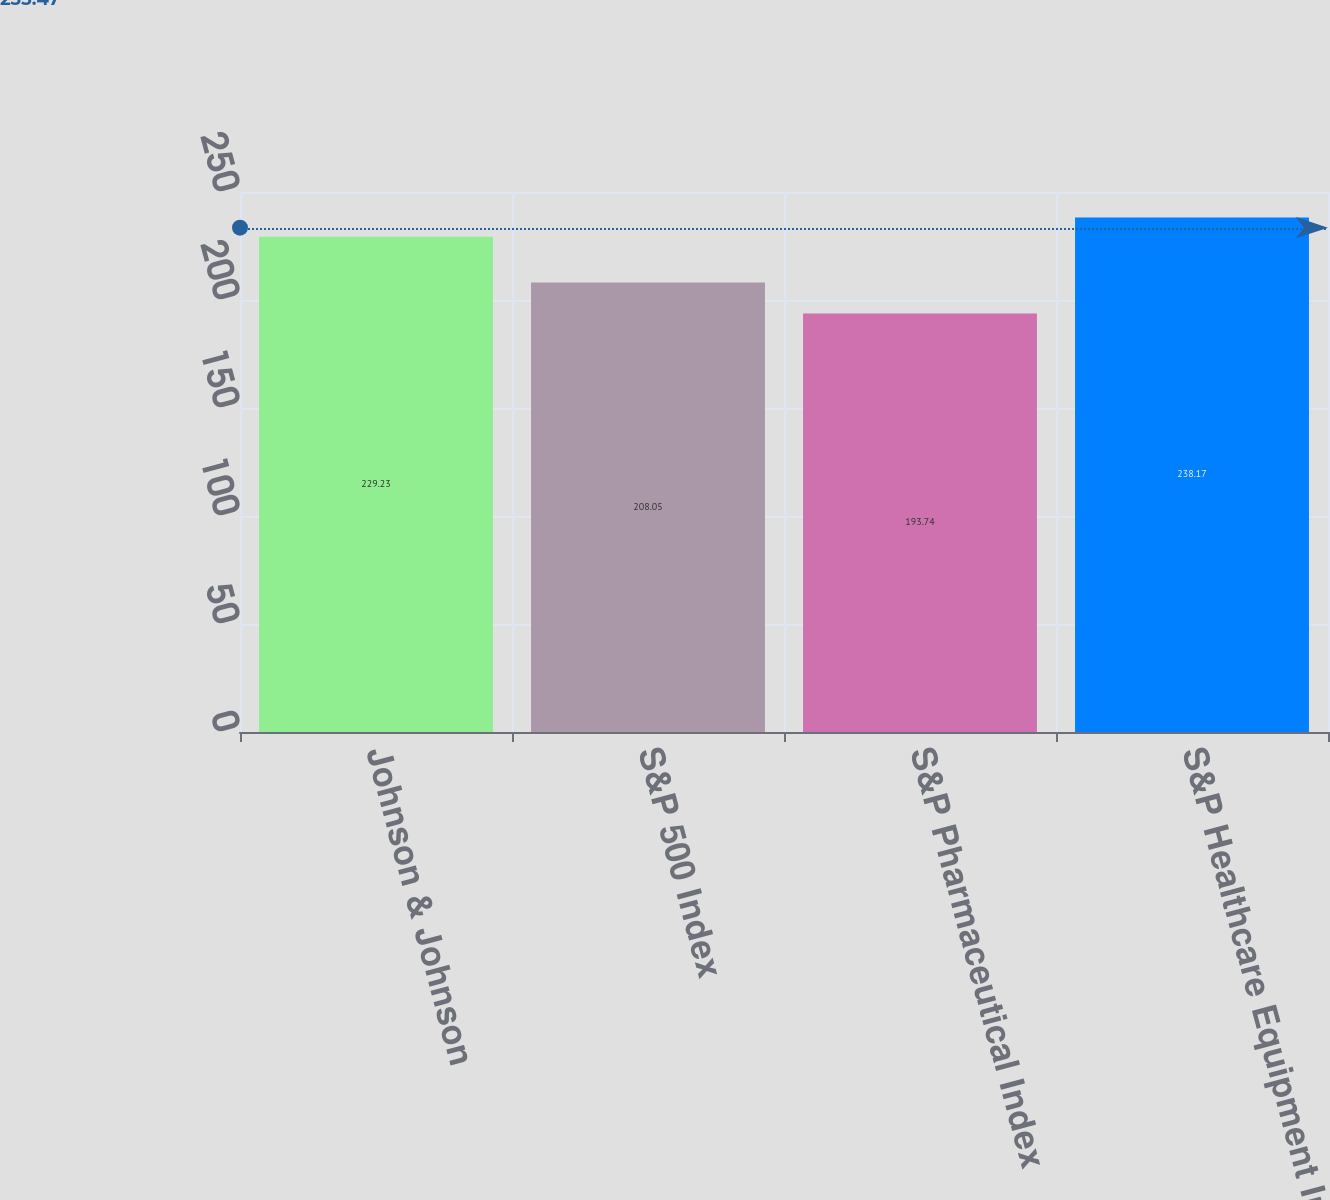<chart> <loc_0><loc_0><loc_500><loc_500><bar_chart><fcel>Johnson & Johnson<fcel>S&P 500 Index<fcel>S&P Pharmaceutical Index<fcel>S&P Healthcare Equipment Index<nl><fcel>229.23<fcel>208.05<fcel>193.74<fcel>238.17<nl></chart> 